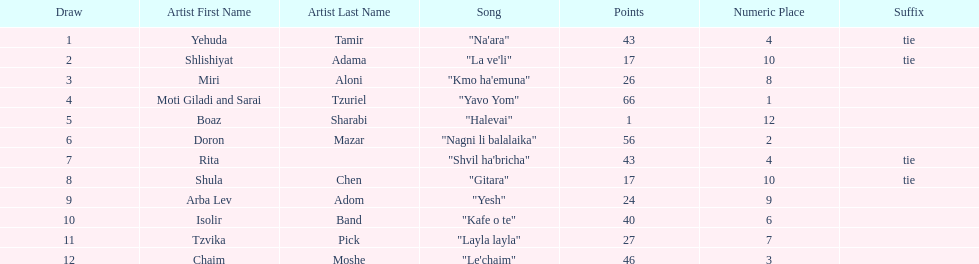Would you be able to parse every entry in this table? {'header': ['Draw', 'Artist First Name', 'Artist Last Name', 'Song', 'Points', 'Numeric Place', 'Suffix'], 'rows': [['1', 'Yehuda', 'Tamir', '"Na\'ara"', '43', '4', 'tie'], ['2', 'Shlishiyat', 'Adama', '"La ve\'li"', '17', '10', 'tie'], ['3', 'Miri', 'Aloni', '"Kmo ha\'emuna"', '26', '8', ''], ['4', 'Moti Giladi and Sarai', 'Tzuriel', '"Yavo Yom"', '66', '1', ''], ['5', 'Boaz', 'Sharabi', '"Halevai"', '1', '12', ''], ['6', 'Doron', 'Mazar', '"Nagni li balalaika"', '56', '2', ''], ['7', 'Rita', '', '"Shvil ha\'bricha"', '43', '4', 'tie'], ['8', 'Shula', 'Chen', '"Gitara"', '17', '10', 'tie'], ['9', 'Arba Lev', 'Adom', '"Yesh"', '24', '9', ''], ['10', 'Isolir', 'Band', '"Kafe o te"', '40', '6', ''], ['11', 'Tzvika', 'Pick', '"Layla layla"', '27', '7', ''], ['12', 'Chaim', 'Moshe', '"Le\'chaim"', '46', '3', '']]} Doron mazar, which artist(s) had the most points? Moti Giladi and Sarai Tzuriel. 